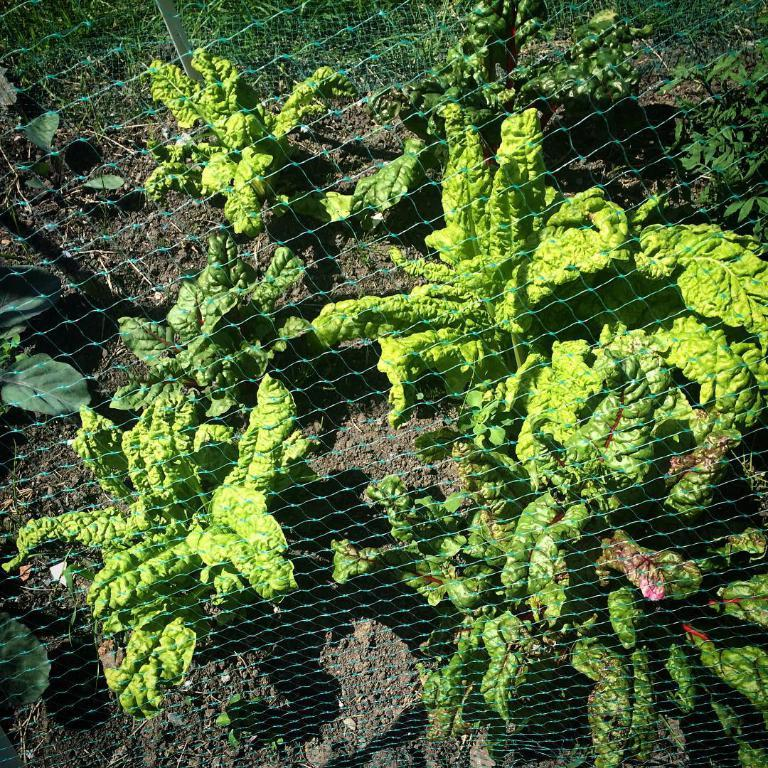What type of living organisms can be seen in the image? Plants can be seen in the image. What other object is present in the image besides the plants? There is a net in the image. Where is the faucet located in the image? There is no faucet present in the image. What type of spark can be seen coming from the plants in the image? There is no spark visible in the image. 